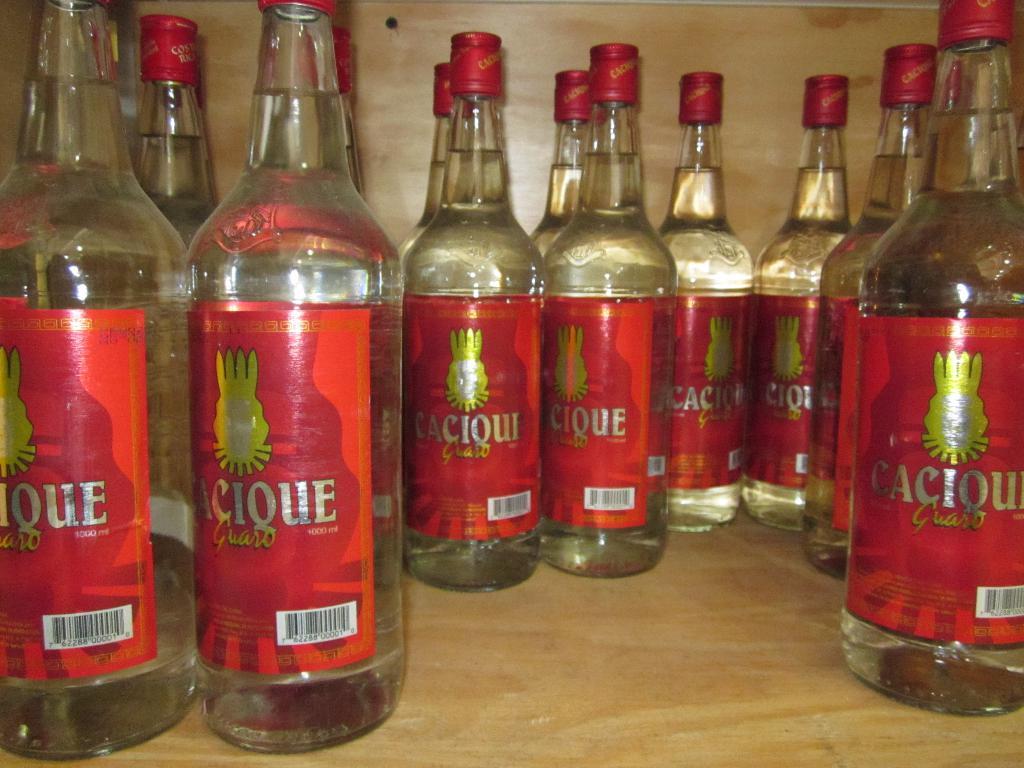What is that liquor called?
Your answer should be compact. Cacique. 